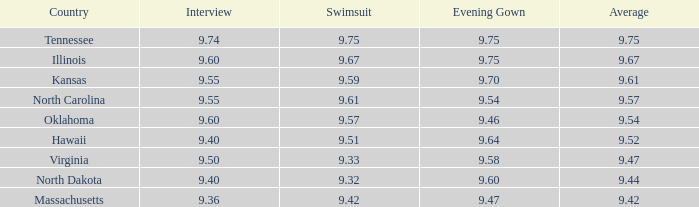In which country was the interview mark North Dakota. 